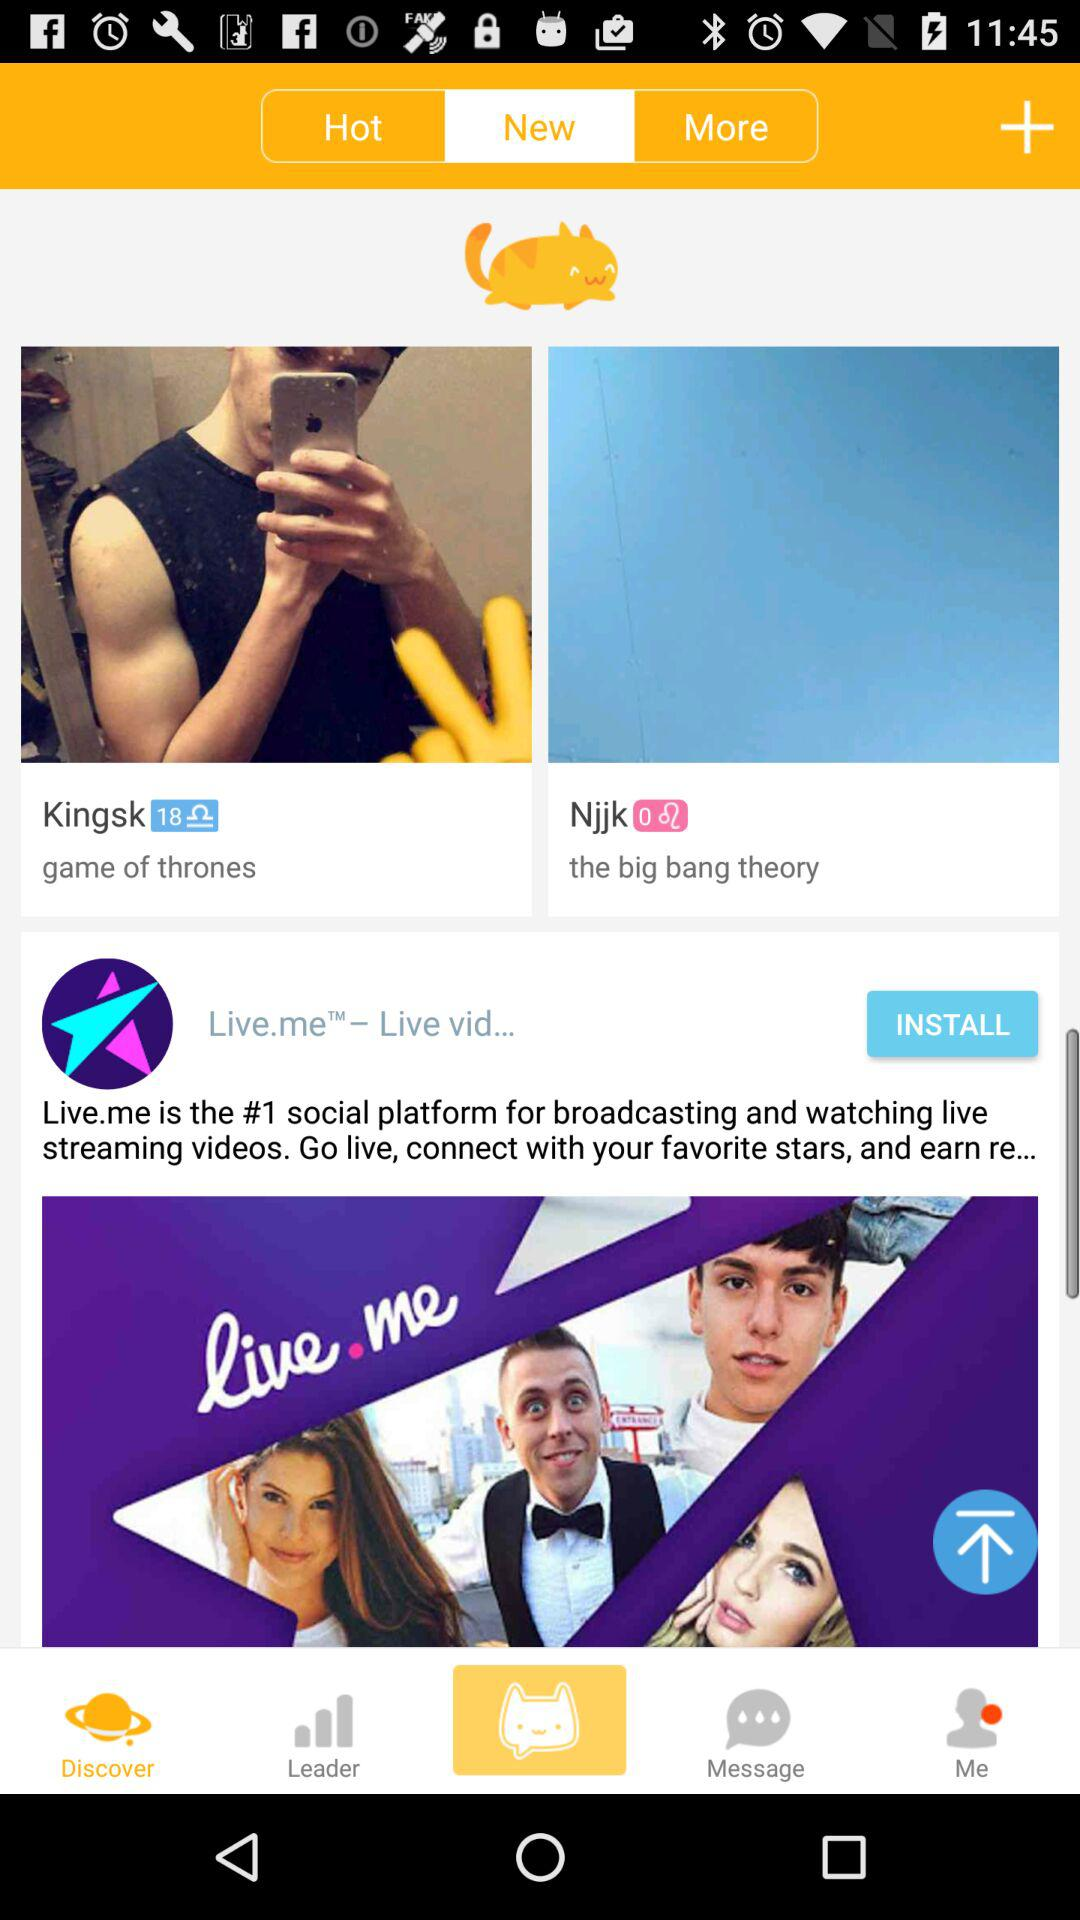Does "MeowChat" have permission to take pictures and record video?
When the provided information is insufficient, respond with <no answer>. <no answer> 